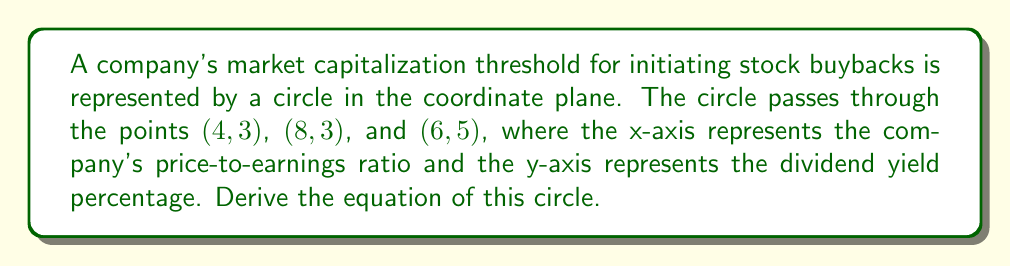Give your solution to this math problem. To derive the equation of the circle, we'll follow these steps:

1) The general equation of a circle is:
   $$(x - h)^2 + (y - k)^2 = r^2$$
   where $(h, k)$ is the center and $r$ is the radius.

2) We can find the center using the perpendicular bisector method:
   a) Midpoint of chord $(4, 3)$ to $(8, 3)$: $(6, 3)$
   b) Midpoint of chord $(4, 3)$ to $(6, 5)$: $(5, 4)$

3) The perpendicular bisector of $(4, 3)$ to $(8, 3)$ is the vertical line $x = 6$.
   The perpendicular bisector of $(4, 3)$ to $(6, 5)$ has slope $-2$ and passes through $(5, 4)$.

4) The equation of the second bisector:
   $y - 4 = -2(x - 5)$
   $y = -2x + 14$

5) The center is where these bisectors intersect:
   $6 = x$
   $y = -2(6) + 14 = 2$

   So, the center is $(6, 2)$.

6) To find the radius, we can use the distance formula from the center to any of the given points:
   $r^2 = (4 - 6)^2 + (3 - 2)^2 = 4 + 1 = 5$

7) Therefore, the equation of the circle is:
   $$(x - 6)^2 + (y - 2)^2 = 5$$
Answer: $(x - 6)^2 + (y - 2)^2 = 5$ 